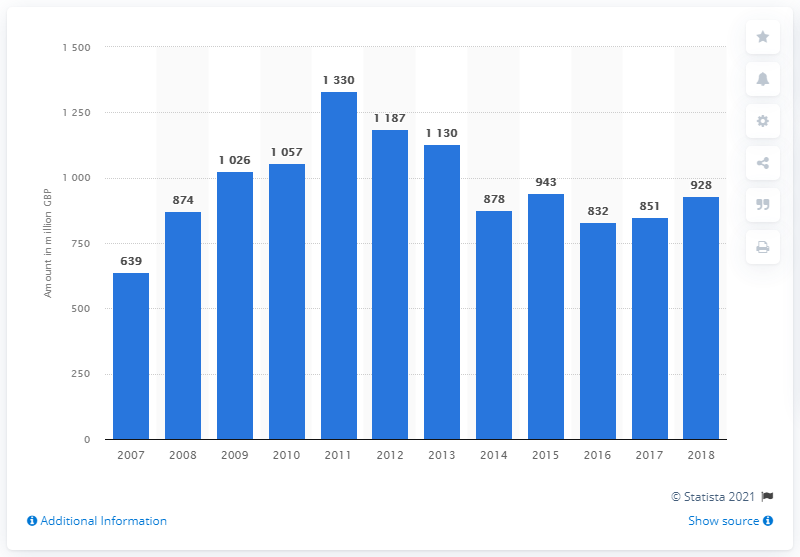List a handful of essential elements in this visual. In 2018, the net written premiums for MAT in the UK was £928 million. 